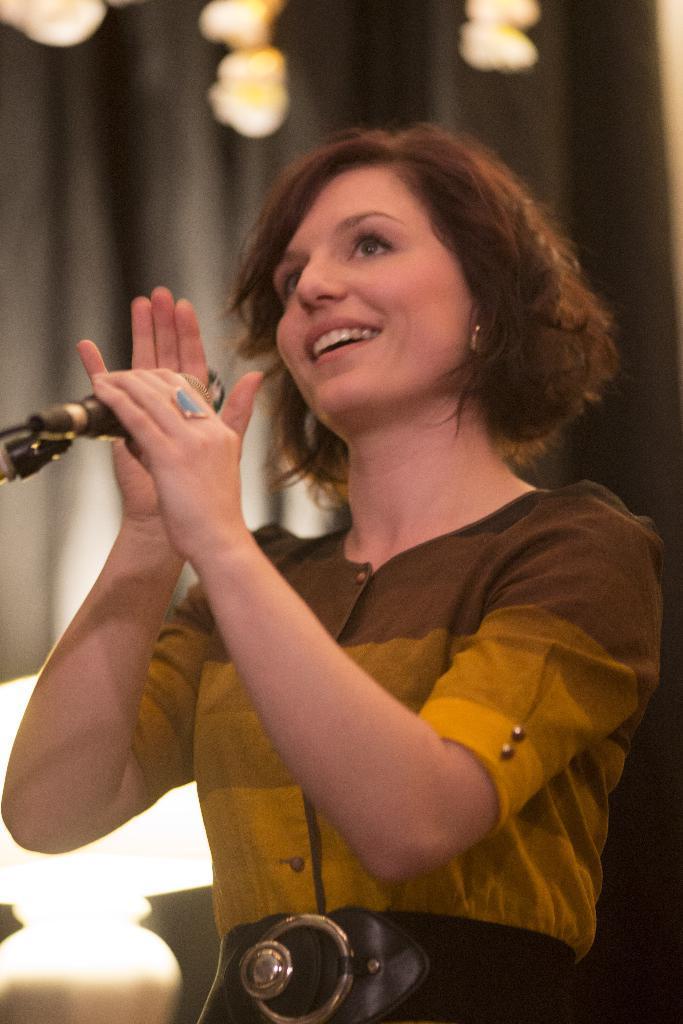Could you give a brief overview of what you see in this image? This person standing and holding microphone and smiling. On the background we can see curtain,lights. 